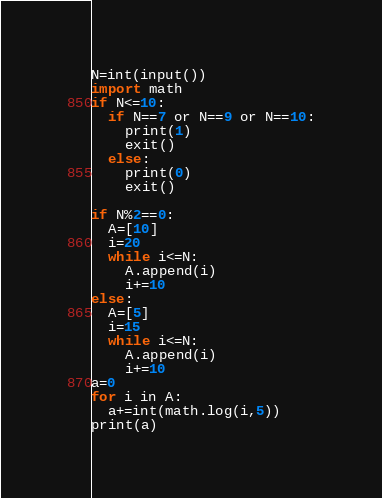Convert code to text. <code><loc_0><loc_0><loc_500><loc_500><_Python_>N=int(input())
import math
if N<=10:
  if N==7 or N==9 or N==10:
    print(1)
    exit()
  else:
    print(0)
    exit()

if N%2==0:
  A=[10]
  i=20
  while i<=N:
    A.append(i)
    i+=10
else:
  A=[5]
  i=15
  while i<=N:
    A.append(i)
    i+=10
a=0
for i in A:
  a+=int(math.log(i,5))
print(a)
</code> 